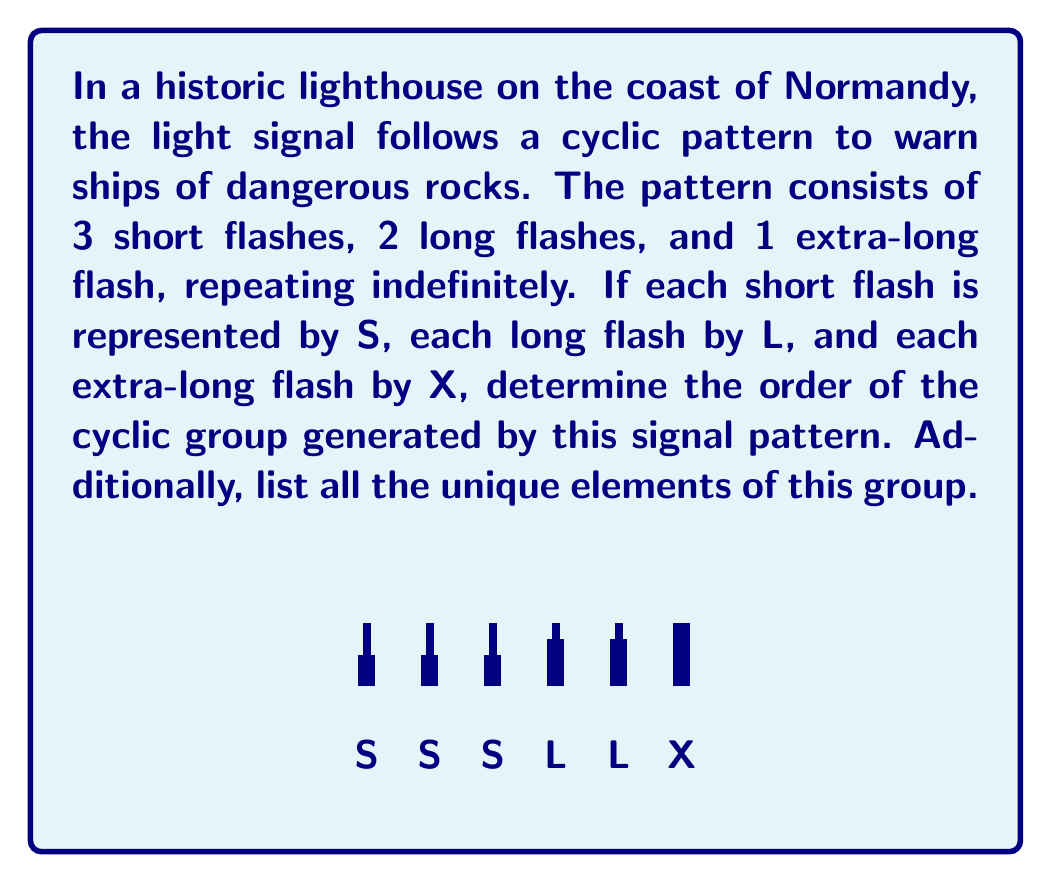What is the answer to this math problem? Let's approach this step-by-step:

1) First, we need to understand what the cyclic group is in this context. The group is generated by the entire pattern SSSLLLX, which we can call the generator of the group.

2) To find the order of the group, we need to determine how many unique rotations of this pattern exist before it repeats.

3) Let's list out the rotations:
   $g^1 = SSSLLLX$
   $g^2 = SSLLLXS$
   $g^3 = SLLLXSS$
   $g^4 = LLLXSSS$
   $g^5 = LLXSSSL$
   $g^6 = LXSSSLL$
   $g^7 = XSSSLLL$

4) We can see that $g^8 = SSSLLLX$, which is the same as $g^1$. This means the pattern repeats after 7 rotations.

5) In group theory, this means that the order of the group is 7. We can write this as $|G| = 7$.

6) The unique elements of this group are the 7 rotations we listed above. In group theory notation:
   $G = \{g^1, g^2, g^3, g^4, g^5, g^6, g^7\}$

7) This group is isomorphic to $\mathbb{Z}_7$, the cyclic group of order 7.
Answer: Order: 7; Elements: $\{SSSLLLX, SSLLLXS, SLLLXSS, LLLXSSS, LLXSSSL, LXSSSLL, XSSSLLL\}$ 